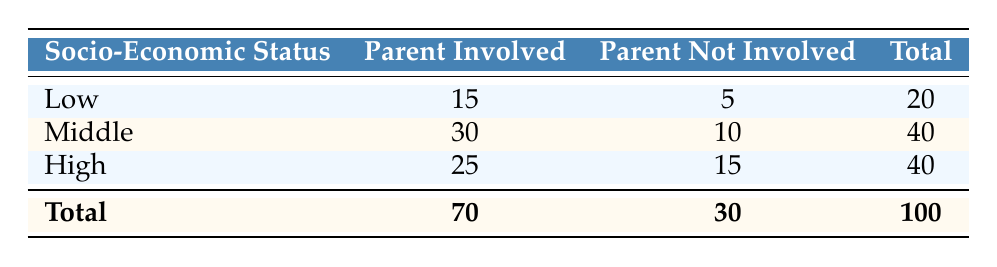What is the total number of therapy sessions attended by parents in the low socio-economic group? The table shows that in the low socio-economic status group, the total number of sessions attended is listed as 20.
Answer: 20 How many parents were not involved in therapy sessions in the middle socio-economic status group? In the middle socio-economic status row, the number of parents not involved is directly listed as 10.
Answer: 10 What is the total number of parents involved across all socio-economic statuses? To find the total number of parents involved, we add the numbers from all three groups: 15 (low) + 30 (middle) + 25 (high) = 70.
Answer: 70 Is it true that more parents are involved in therapy sessions in the middle socio-economic group than in the high socio-economic group? The middle group has 30 parents involved, while the high group has 25 involved. Since 30 is greater than 25, the statement is true.
Answer: Yes What percentage of parents in the low socio-economic group were involved in therapy sessions? In the low socio-economic group, 15 parents were involved out of a total of 20 sessions attended. The percentage is calculated as (15/20) * 100 = 75%.
Answer: 75% How many more parents were involved in sessions in the middle group compared to the low group? The middle group has 30 parents involved while the low group has 15. The difference is 30 - 15 = 15 parents.
Answer: 15 What is the ratio of parents involved to parents not involved in therapy sessions for the high socio-economic group? In the high group, 25 parents were involved and 15 were not involved. The ratio is 25:15 which can be simplified to 5:3.
Answer: 5:3 What is the average number of parents involved in therapy sessions across all socio-economic statuses? To find the average, we first sum the number of parents involved: 15 + 30 + 25 = 70. There are 3 groups, so the average is 70 / 3 ≈ 23.33.
Answer: 23.33 Which socio-economic group has the highest total number of sessions attended? By looking at the total for each group at the bottom of the table, both the middle and high socio-economic groups have a total of 40 sessions each, which is the highest compared to the low group.
Answer: Middle and High 